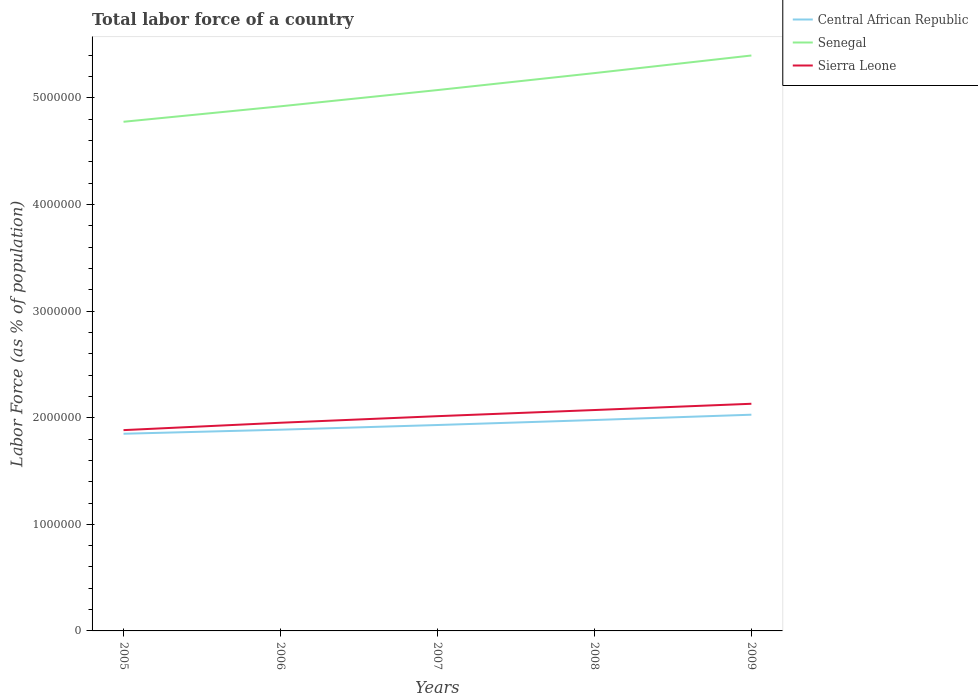Is the number of lines equal to the number of legend labels?
Your answer should be very brief. Yes. Across all years, what is the maximum percentage of labor force in Central African Republic?
Keep it short and to the point. 1.85e+06. What is the total percentage of labor force in Central African Republic in the graph?
Provide a succinct answer. -1.41e+05. What is the difference between the highest and the second highest percentage of labor force in Central African Republic?
Give a very brief answer. 1.79e+05. How many lines are there?
Make the answer very short. 3. How many years are there in the graph?
Your answer should be very brief. 5. Are the values on the major ticks of Y-axis written in scientific E-notation?
Your answer should be compact. No. Does the graph contain any zero values?
Give a very brief answer. No. What is the title of the graph?
Make the answer very short. Total labor force of a country. What is the label or title of the X-axis?
Your answer should be compact. Years. What is the label or title of the Y-axis?
Ensure brevity in your answer.  Labor Force (as % of population). What is the Labor Force (as % of population) in Central African Republic in 2005?
Your answer should be very brief. 1.85e+06. What is the Labor Force (as % of population) of Senegal in 2005?
Offer a terse response. 4.78e+06. What is the Labor Force (as % of population) of Sierra Leone in 2005?
Your answer should be very brief. 1.88e+06. What is the Labor Force (as % of population) of Central African Republic in 2006?
Offer a terse response. 1.89e+06. What is the Labor Force (as % of population) in Senegal in 2006?
Provide a short and direct response. 4.92e+06. What is the Labor Force (as % of population) in Sierra Leone in 2006?
Offer a terse response. 1.95e+06. What is the Labor Force (as % of population) of Central African Republic in 2007?
Ensure brevity in your answer.  1.93e+06. What is the Labor Force (as % of population) in Senegal in 2007?
Provide a short and direct response. 5.07e+06. What is the Labor Force (as % of population) of Sierra Leone in 2007?
Ensure brevity in your answer.  2.01e+06. What is the Labor Force (as % of population) in Central African Republic in 2008?
Ensure brevity in your answer.  1.98e+06. What is the Labor Force (as % of population) of Senegal in 2008?
Your answer should be very brief. 5.23e+06. What is the Labor Force (as % of population) in Sierra Leone in 2008?
Provide a succinct answer. 2.07e+06. What is the Labor Force (as % of population) of Central African Republic in 2009?
Offer a terse response. 2.03e+06. What is the Labor Force (as % of population) of Senegal in 2009?
Give a very brief answer. 5.40e+06. What is the Labor Force (as % of population) of Sierra Leone in 2009?
Make the answer very short. 2.13e+06. Across all years, what is the maximum Labor Force (as % of population) of Central African Republic?
Your answer should be compact. 2.03e+06. Across all years, what is the maximum Labor Force (as % of population) in Senegal?
Provide a short and direct response. 5.40e+06. Across all years, what is the maximum Labor Force (as % of population) of Sierra Leone?
Your response must be concise. 2.13e+06. Across all years, what is the minimum Labor Force (as % of population) in Central African Republic?
Offer a terse response. 1.85e+06. Across all years, what is the minimum Labor Force (as % of population) of Senegal?
Offer a very short reply. 4.78e+06. Across all years, what is the minimum Labor Force (as % of population) of Sierra Leone?
Offer a very short reply. 1.88e+06. What is the total Labor Force (as % of population) of Central African Republic in the graph?
Your answer should be compact. 9.68e+06. What is the total Labor Force (as % of population) of Senegal in the graph?
Provide a succinct answer. 2.54e+07. What is the total Labor Force (as % of population) in Sierra Leone in the graph?
Your response must be concise. 1.01e+07. What is the difference between the Labor Force (as % of population) of Central African Republic in 2005 and that in 2006?
Your answer should be very brief. -3.81e+04. What is the difference between the Labor Force (as % of population) of Senegal in 2005 and that in 2006?
Offer a terse response. -1.45e+05. What is the difference between the Labor Force (as % of population) of Sierra Leone in 2005 and that in 2006?
Provide a succinct answer. -6.92e+04. What is the difference between the Labor Force (as % of population) of Central African Republic in 2005 and that in 2007?
Make the answer very short. -8.20e+04. What is the difference between the Labor Force (as % of population) of Senegal in 2005 and that in 2007?
Provide a succinct answer. -2.97e+05. What is the difference between the Labor Force (as % of population) in Sierra Leone in 2005 and that in 2007?
Make the answer very short. -1.31e+05. What is the difference between the Labor Force (as % of population) of Central African Republic in 2005 and that in 2008?
Provide a short and direct response. -1.29e+05. What is the difference between the Labor Force (as % of population) of Senegal in 2005 and that in 2008?
Provide a short and direct response. -4.57e+05. What is the difference between the Labor Force (as % of population) in Sierra Leone in 2005 and that in 2008?
Provide a succinct answer. -1.88e+05. What is the difference between the Labor Force (as % of population) of Central African Republic in 2005 and that in 2009?
Your answer should be very brief. -1.79e+05. What is the difference between the Labor Force (as % of population) of Senegal in 2005 and that in 2009?
Give a very brief answer. -6.22e+05. What is the difference between the Labor Force (as % of population) in Sierra Leone in 2005 and that in 2009?
Provide a succinct answer. -2.47e+05. What is the difference between the Labor Force (as % of population) of Central African Republic in 2006 and that in 2007?
Provide a short and direct response. -4.39e+04. What is the difference between the Labor Force (as % of population) in Senegal in 2006 and that in 2007?
Make the answer very short. -1.52e+05. What is the difference between the Labor Force (as % of population) of Sierra Leone in 2006 and that in 2007?
Your response must be concise. -6.16e+04. What is the difference between the Labor Force (as % of population) in Central African Republic in 2006 and that in 2008?
Provide a succinct answer. -9.08e+04. What is the difference between the Labor Force (as % of population) in Senegal in 2006 and that in 2008?
Keep it short and to the point. -3.12e+05. What is the difference between the Labor Force (as % of population) of Sierra Leone in 2006 and that in 2008?
Keep it short and to the point. -1.19e+05. What is the difference between the Labor Force (as % of population) in Central African Republic in 2006 and that in 2009?
Keep it short and to the point. -1.41e+05. What is the difference between the Labor Force (as % of population) of Senegal in 2006 and that in 2009?
Keep it short and to the point. -4.77e+05. What is the difference between the Labor Force (as % of population) in Sierra Leone in 2006 and that in 2009?
Offer a very short reply. -1.78e+05. What is the difference between the Labor Force (as % of population) of Central African Republic in 2007 and that in 2008?
Offer a terse response. -4.70e+04. What is the difference between the Labor Force (as % of population) in Senegal in 2007 and that in 2008?
Give a very brief answer. -1.59e+05. What is the difference between the Labor Force (as % of population) of Sierra Leone in 2007 and that in 2008?
Your answer should be very brief. -5.76e+04. What is the difference between the Labor Force (as % of population) of Central African Republic in 2007 and that in 2009?
Ensure brevity in your answer.  -9.67e+04. What is the difference between the Labor Force (as % of population) in Senegal in 2007 and that in 2009?
Offer a very short reply. -3.24e+05. What is the difference between the Labor Force (as % of population) in Sierra Leone in 2007 and that in 2009?
Give a very brief answer. -1.16e+05. What is the difference between the Labor Force (as % of population) in Central African Republic in 2008 and that in 2009?
Your answer should be compact. -4.98e+04. What is the difference between the Labor Force (as % of population) of Senegal in 2008 and that in 2009?
Give a very brief answer. -1.65e+05. What is the difference between the Labor Force (as % of population) of Sierra Leone in 2008 and that in 2009?
Keep it short and to the point. -5.88e+04. What is the difference between the Labor Force (as % of population) in Central African Republic in 2005 and the Labor Force (as % of population) in Senegal in 2006?
Your response must be concise. -3.07e+06. What is the difference between the Labor Force (as % of population) in Central African Republic in 2005 and the Labor Force (as % of population) in Sierra Leone in 2006?
Make the answer very short. -1.03e+05. What is the difference between the Labor Force (as % of population) in Senegal in 2005 and the Labor Force (as % of population) in Sierra Leone in 2006?
Ensure brevity in your answer.  2.82e+06. What is the difference between the Labor Force (as % of population) of Central African Republic in 2005 and the Labor Force (as % of population) of Senegal in 2007?
Make the answer very short. -3.22e+06. What is the difference between the Labor Force (as % of population) of Central African Republic in 2005 and the Labor Force (as % of population) of Sierra Leone in 2007?
Provide a succinct answer. -1.65e+05. What is the difference between the Labor Force (as % of population) of Senegal in 2005 and the Labor Force (as % of population) of Sierra Leone in 2007?
Keep it short and to the point. 2.76e+06. What is the difference between the Labor Force (as % of population) of Central African Republic in 2005 and the Labor Force (as % of population) of Senegal in 2008?
Your answer should be very brief. -3.38e+06. What is the difference between the Labor Force (as % of population) in Central African Republic in 2005 and the Labor Force (as % of population) in Sierra Leone in 2008?
Your answer should be compact. -2.23e+05. What is the difference between the Labor Force (as % of population) in Senegal in 2005 and the Labor Force (as % of population) in Sierra Leone in 2008?
Your answer should be very brief. 2.70e+06. What is the difference between the Labor Force (as % of population) in Central African Republic in 2005 and the Labor Force (as % of population) in Senegal in 2009?
Keep it short and to the point. -3.55e+06. What is the difference between the Labor Force (as % of population) in Central African Republic in 2005 and the Labor Force (as % of population) in Sierra Leone in 2009?
Keep it short and to the point. -2.81e+05. What is the difference between the Labor Force (as % of population) of Senegal in 2005 and the Labor Force (as % of population) of Sierra Leone in 2009?
Offer a very short reply. 2.65e+06. What is the difference between the Labor Force (as % of population) of Central African Republic in 2006 and the Labor Force (as % of population) of Senegal in 2007?
Offer a very short reply. -3.19e+06. What is the difference between the Labor Force (as % of population) in Central African Republic in 2006 and the Labor Force (as % of population) in Sierra Leone in 2007?
Give a very brief answer. -1.27e+05. What is the difference between the Labor Force (as % of population) of Senegal in 2006 and the Labor Force (as % of population) of Sierra Leone in 2007?
Offer a very short reply. 2.91e+06. What is the difference between the Labor Force (as % of population) in Central African Republic in 2006 and the Labor Force (as % of population) in Senegal in 2008?
Provide a short and direct response. -3.35e+06. What is the difference between the Labor Force (as % of population) in Central African Republic in 2006 and the Labor Force (as % of population) in Sierra Leone in 2008?
Keep it short and to the point. -1.84e+05. What is the difference between the Labor Force (as % of population) of Senegal in 2006 and the Labor Force (as % of population) of Sierra Leone in 2008?
Your answer should be very brief. 2.85e+06. What is the difference between the Labor Force (as % of population) in Central African Republic in 2006 and the Labor Force (as % of population) in Senegal in 2009?
Make the answer very short. -3.51e+06. What is the difference between the Labor Force (as % of population) in Central African Republic in 2006 and the Labor Force (as % of population) in Sierra Leone in 2009?
Give a very brief answer. -2.43e+05. What is the difference between the Labor Force (as % of population) in Senegal in 2006 and the Labor Force (as % of population) in Sierra Leone in 2009?
Ensure brevity in your answer.  2.79e+06. What is the difference between the Labor Force (as % of population) of Central African Republic in 2007 and the Labor Force (as % of population) of Senegal in 2008?
Your answer should be compact. -3.30e+06. What is the difference between the Labor Force (as % of population) of Central African Republic in 2007 and the Labor Force (as % of population) of Sierra Leone in 2008?
Provide a short and direct response. -1.41e+05. What is the difference between the Labor Force (as % of population) of Senegal in 2007 and the Labor Force (as % of population) of Sierra Leone in 2008?
Keep it short and to the point. 3.00e+06. What is the difference between the Labor Force (as % of population) of Central African Republic in 2007 and the Labor Force (as % of population) of Senegal in 2009?
Give a very brief answer. -3.47e+06. What is the difference between the Labor Force (as % of population) of Central African Republic in 2007 and the Labor Force (as % of population) of Sierra Leone in 2009?
Ensure brevity in your answer.  -1.99e+05. What is the difference between the Labor Force (as % of population) in Senegal in 2007 and the Labor Force (as % of population) in Sierra Leone in 2009?
Your answer should be compact. 2.94e+06. What is the difference between the Labor Force (as % of population) of Central African Republic in 2008 and the Labor Force (as % of population) of Senegal in 2009?
Provide a short and direct response. -3.42e+06. What is the difference between the Labor Force (as % of population) of Central African Republic in 2008 and the Labor Force (as % of population) of Sierra Leone in 2009?
Your answer should be compact. -1.52e+05. What is the difference between the Labor Force (as % of population) in Senegal in 2008 and the Labor Force (as % of population) in Sierra Leone in 2009?
Provide a succinct answer. 3.10e+06. What is the average Labor Force (as % of population) of Central African Republic per year?
Ensure brevity in your answer.  1.94e+06. What is the average Labor Force (as % of population) of Senegal per year?
Offer a terse response. 5.08e+06. What is the average Labor Force (as % of population) in Sierra Leone per year?
Offer a very short reply. 2.01e+06. In the year 2005, what is the difference between the Labor Force (as % of population) in Central African Republic and Labor Force (as % of population) in Senegal?
Give a very brief answer. -2.93e+06. In the year 2005, what is the difference between the Labor Force (as % of population) of Central African Republic and Labor Force (as % of population) of Sierra Leone?
Your answer should be very brief. -3.41e+04. In the year 2005, what is the difference between the Labor Force (as % of population) of Senegal and Labor Force (as % of population) of Sierra Leone?
Keep it short and to the point. 2.89e+06. In the year 2006, what is the difference between the Labor Force (as % of population) of Central African Republic and Labor Force (as % of population) of Senegal?
Make the answer very short. -3.03e+06. In the year 2006, what is the difference between the Labor Force (as % of population) of Central African Republic and Labor Force (as % of population) of Sierra Leone?
Your answer should be very brief. -6.52e+04. In the year 2006, what is the difference between the Labor Force (as % of population) of Senegal and Labor Force (as % of population) of Sierra Leone?
Offer a terse response. 2.97e+06. In the year 2007, what is the difference between the Labor Force (as % of population) in Central African Republic and Labor Force (as % of population) in Senegal?
Provide a short and direct response. -3.14e+06. In the year 2007, what is the difference between the Labor Force (as % of population) in Central African Republic and Labor Force (as % of population) in Sierra Leone?
Ensure brevity in your answer.  -8.30e+04. In the year 2007, what is the difference between the Labor Force (as % of population) of Senegal and Labor Force (as % of population) of Sierra Leone?
Provide a short and direct response. 3.06e+06. In the year 2008, what is the difference between the Labor Force (as % of population) of Central African Republic and Labor Force (as % of population) of Senegal?
Offer a very short reply. -3.25e+06. In the year 2008, what is the difference between the Labor Force (as % of population) of Central African Republic and Labor Force (as % of population) of Sierra Leone?
Offer a very short reply. -9.36e+04. In the year 2008, what is the difference between the Labor Force (as % of population) of Senegal and Labor Force (as % of population) of Sierra Leone?
Provide a succinct answer. 3.16e+06. In the year 2009, what is the difference between the Labor Force (as % of population) in Central African Republic and Labor Force (as % of population) in Senegal?
Provide a succinct answer. -3.37e+06. In the year 2009, what is the difference between the Labor Force (as % of population) of Central African Republic and Labor Force (as % of population) of Sierra Leone?
Give a very brief answer. -1.03e+05. In the year 2009, what is the difference between the Labor Force (as % of population) in Senegal and Labor Force (as % of population) in Sierra Leone?
Give a very brief answer. 3.27e+06. What is the ratio of the Labor Force (as % of population) of Central African Republic in 2005 to that in 2006?
Offer a terse response. 0.98. What is the ratio of the Labor Force (as % of population) of Senegal in 2005 to that in 2006?
Your response must be concise. 0.97. What is the ratio of the Labor Force (as % of population) in Sierra Leone in 2005 to that in 2006?
Provide a succinct answer. 0.96. What is the ratio of the Labor Force (as % of population) of Central African Republic in 2005 to that in 2007?
Make the answer very short. 0.96. What is the ratio of the Labor Force (as % of population) in Senegal in 2005 to that in 2007?
Make the answer very short. 0.94. What is the ratio of the Labor Force (as % of population) of Sierra Leone in 2005 to that in 2007?
Your answer should be very brief. 0.94. What is the ratio of the Labor Force (as % of population) in Central African Republic in 2005 to that in 2008?
Make the answer very short. 0.93. What is the ratio of the Labor Force (as % of population) in Senegal in 2005 to that in 2008?
Make the answer very short. 0.91. What is the ratio of the Labor Force (as % of population) in Central African Republic in 2005 to that in 2009?
Your answer should be very brief. 0.91. What is the ratio of the Labor Force (as % of population) of Senegal in 2005 to that in 2009?
Ensure brevity in your answer.  0.88. What is the ratio of the Labor Force (as % of population) in Sierra Leone in 2005 to that in 2009?
Your response must be concise. 0.88. What is the ratio of the Labor Force (as % of population) in Central African Republic in 2006 to that in 2007?
Make the answer very short. 0.98. What is the ratio of the Labor Force (as % of population) of Senegal in 2006 to that in 2007?
Keep it short and to the point. 0.97. What is the ratio of the Labor Force (as % of population) in Sierra Leone in 2006 to that in 2007?
Ensure brevity in your answer.  0.97. What is the ratio of the Labor Force (as % of population) of Central African Republic in 2006 to that in 2008?
Offer a terse response. 0.95. What is the ratio of the Labor Force (as % of population) of Senegal in 2006 to that in 2008?
Provide a short and direct response. 0.94. What is the ratio of the Labor Force (as % of population) in Sierra Leone in 2006 to that in 2008?
Keep it short and to the point. 0.94. What is the ratio of the Labor Force (as % of population) of Central African Republic in 2006 to that in 2009?
Provide a short and direct response. 0.93. What is the ratio of the Labor Force (as % of population) in Senegal in 2006 to that in 2009?
Your answer should be very brief. 0.91. What is the ratio of the Labor Force (as % of population) in Sierra Leone in 2006 to that in 2009?
Provide a succinct answer. 0.92. What is the ratio of the Labor Force (as % of population) of Central African Republic in 2007 to that in 2008?
Give a very brief answer. 0.98. What is the ratio of the Labor Force (as % of population) in Senegal in 2007 to that in 2008?
Your answer should be very brief. 0.97. What is the ratio of the Labor Force (as % of population) in Sierra Leone in 2007 to that in 2008?
Provide a succinct answer. 0.97. What is the ratio of the Labor Force (as % of population) of Central African Republic in 2007 to that in 2009?
Offer a terse response. 0.95. What is the ratio of the Labor Force (as % of population) in Senegal in 2007 to that in 2009?
Keep it short and to the point. 0.94. What is the ratio of the Labor Force (as % of population) of Sierra Leone in 2007 to that in 2009?
Ensure brevity in your answer.  0.95. What is the ratio of the Labor Force (as % of population) in Central African Republic in 2008 to that in 2009?
Offer a very short reply. 0.98. What is the ratio of the Labor Force (as % of population) of Senegal in 2008 to that in 2009?
Your answer should be compact. 0.97. What is the ratio of the Labor Force (as % of population) in Sierra Leone in 2008 to that in 2009?
Ensure brevity in your answer.  0.97. What is the difference between the highest and the second highest Labor Force (as % of population) of Central African Republic?
Your response must be concise. 4.98e+04. What is the difference between the highest and the second highest Labor Force (as % of population) in Senegal?
Offer a very short reply. 1.65e+05. What is the difference between the highest and the second highest Labor Force (as % of population) of Sierra Leone?
Your answer should be very brief. 5.88e+04. What is the difference between the highest and the lowest Labor Force (as % of population) in Central African Republic?
Offer a very short reply. 1.79e+05. What is the difference between the highest and the lowest Labor Force (as % of population) in Senegal?
Your answer should be compact. 6.22e+05. What is the difference between the highest and the lowest Labor Force (as % of population) of Sierra Leone?
Your answer should be very brief. 2.47e+05. 